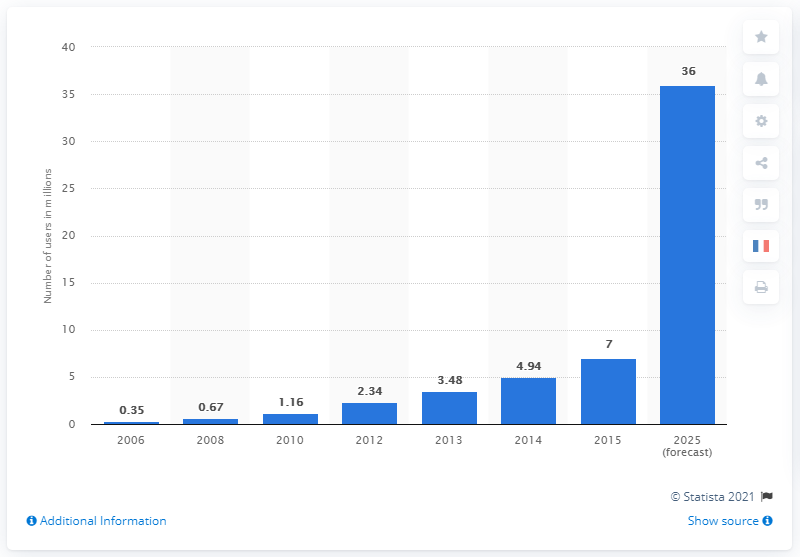Identify some key points in this picture. In 2015, there were 7 car sharing users. 